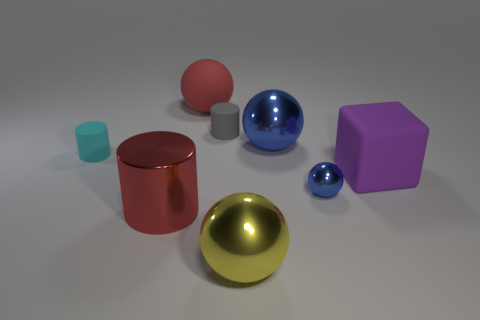Subtract all red matte balls. How many balls are left? 3 Add 2 tiny yellow matte balls. How many objects exist? 10 Subtract all gray cubes. How many blue balls are left? 2 Subtract all red cylinders. How many cylinders are left? 2 Subtract all cylinders. How many objects are left? 5 Subtract 1 cylinders. How many cylinders are left? 2 Subtract all red cylinders. Subtract all brown cubes. How many cylinders are left? 2 Subtract all small balls. Subtract all cyan cylinders. How many objects are left? 6 Add 3 gray things. How many gray things are left? 4 Add 7 cyan things. How many cyan things exist? 8 